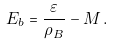<formula> <loc_0><loc_0><loc_500><loc_500>E _ { b } = \frac { \varepsilon } { \rho _ { B } } - M \, .</formula> 